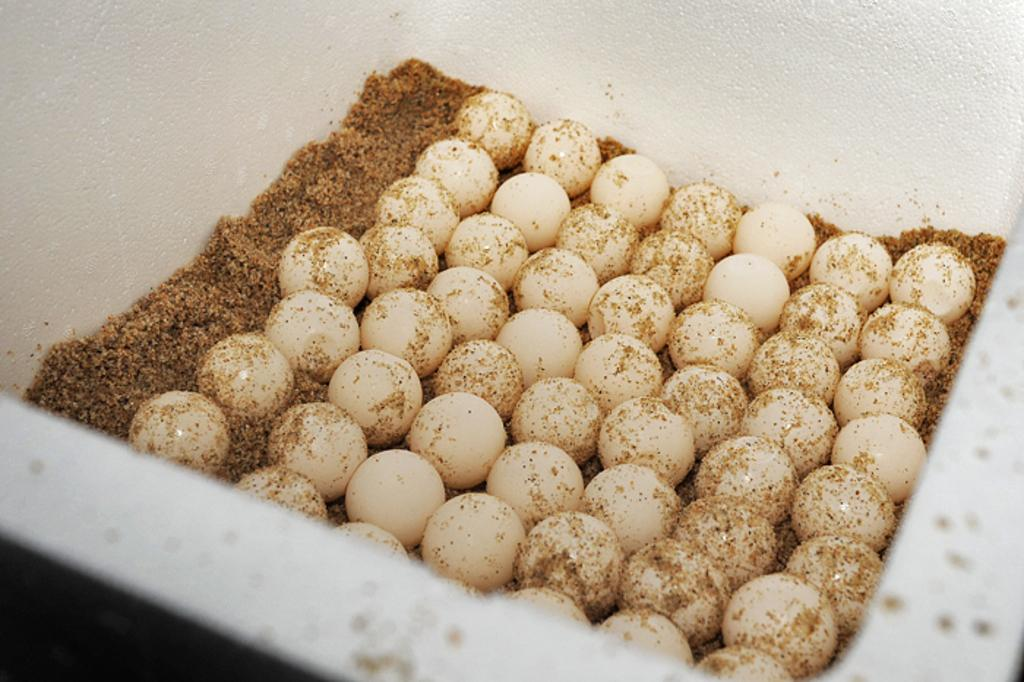What is the main object in the image? There is a white box in the image. What is inside the white box? The white box contains eggs. Is there anything else in the white box besides the eggs? Yes, there is a brown color powdered thing in the white box. What is the temperature of the eggs in the image? The temperature of the eggs cannot be determined from the image alone. --- 